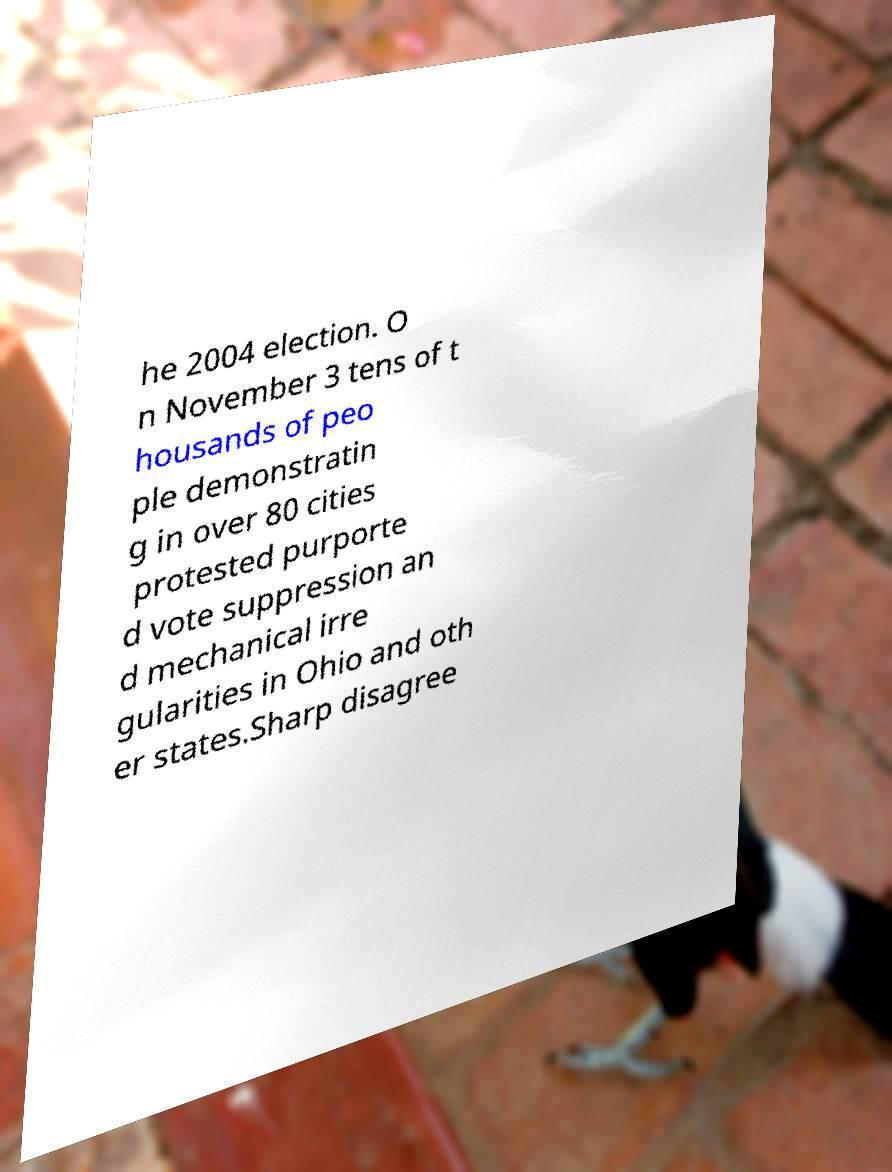I need the written content from this picture converted into text. Can you do that? he 2004 election. O n November 3 tens of t housands of peo ple demonstratin g in over 80 cities protested purporte d vote suppression an d mechanical irre gularities in Ohio and oth er states.Sharp disagree 